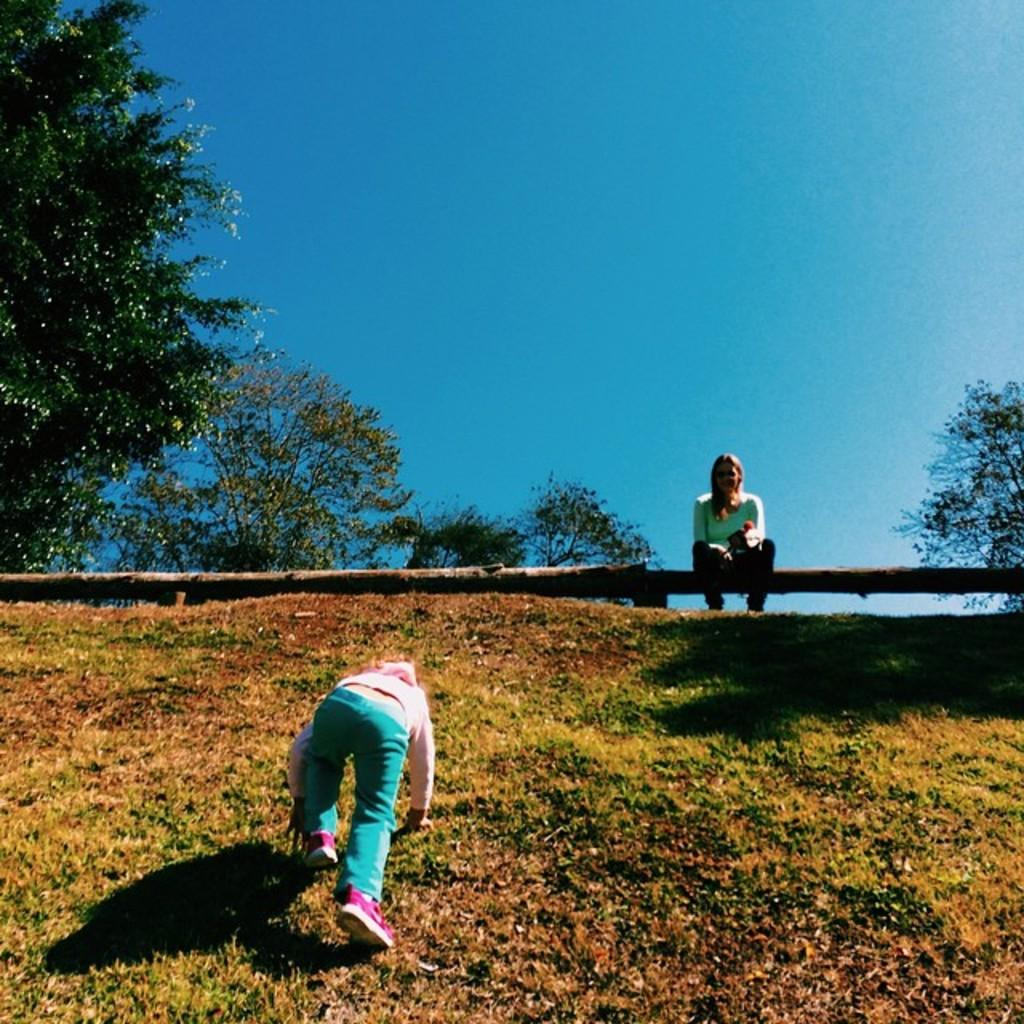What is the person in the image doing? The person is climbing on a hill. Can you describe the lady's position in the image? The lady is sitting on a wooden log. What can be seen in the background of the image? The sky and trees are visible in the background. What color is the lady's hair in the image? There is no information about the lady's hair color in the provided facts, so we cannot answer that question. 